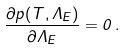Convert formula to latex. <formula><loc_0><loc_0><loc_500><loc_500>\frac { \partial p ( T , \Lambda _ { E } ) } { \partial \Lambda _ { E } } = 0 \, .</formula> 